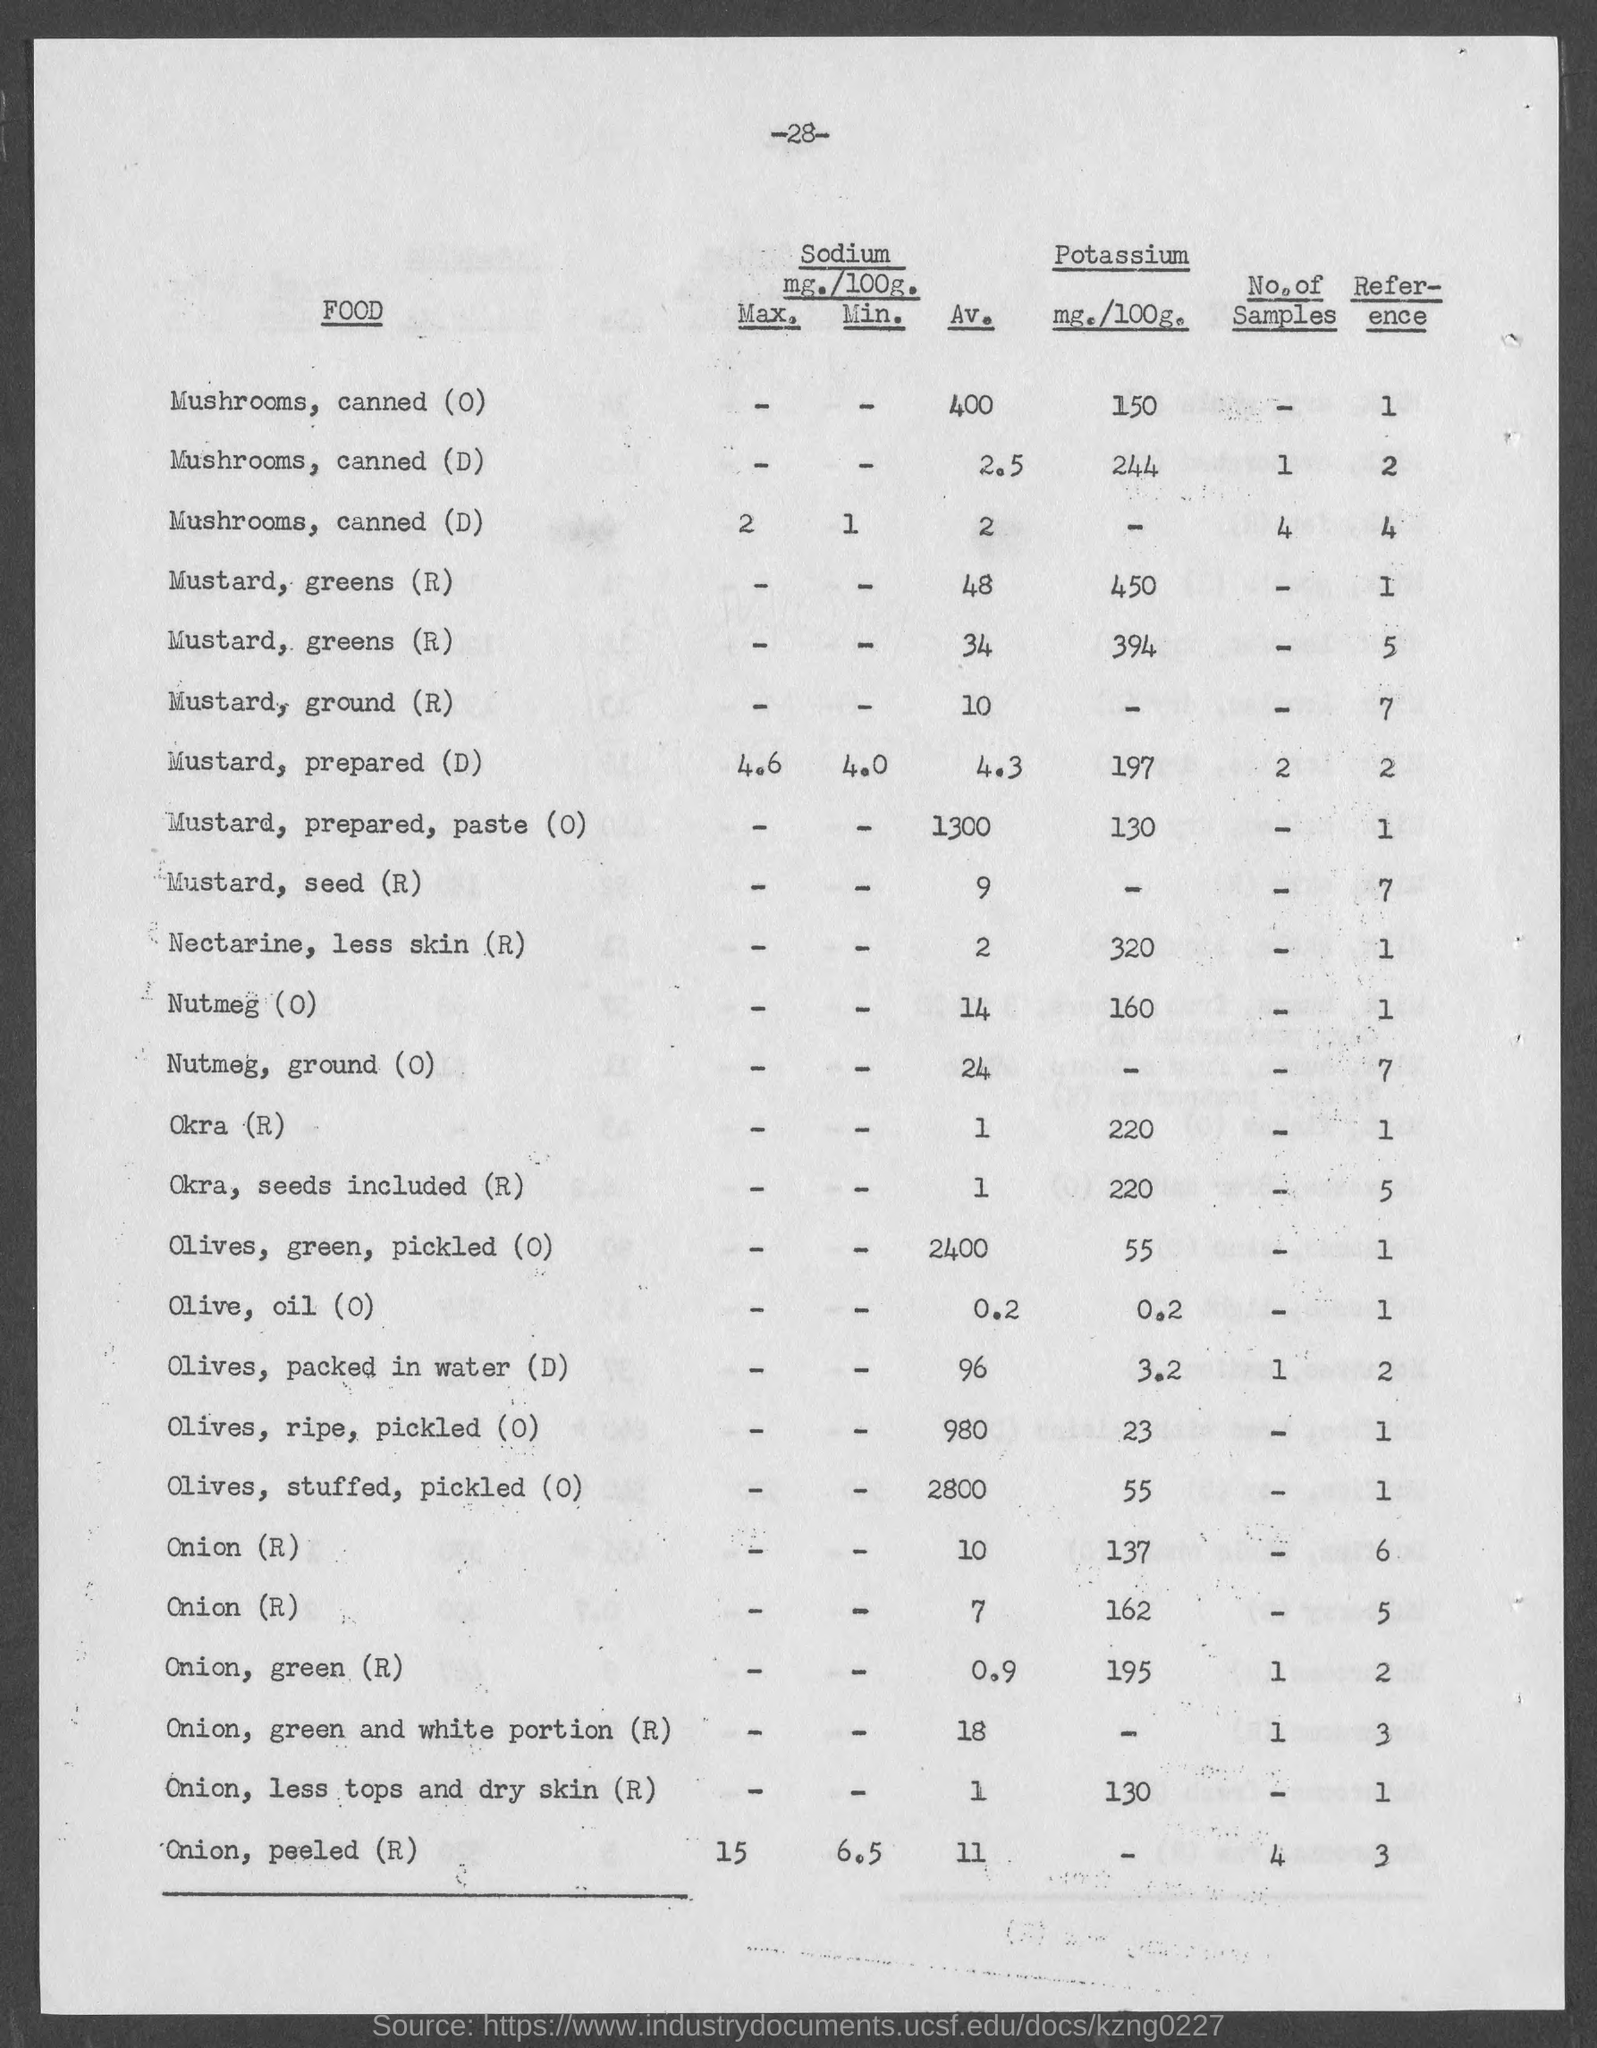List a handful of essential elements in this visual. The potassium content of Mustard, prepared (D) is 197 mg per 100 grams. The potassium content of okra, measured in milligrams per 100 grams, is 220. The potassium content of Mustard, prepared, paste (O) is 130 mg per 100 grams. The potassium content of nectarine with less skin (R) is approximately 320 milligrams per 100 grams. The potassium content of olive oil is approximately 0.2 milligrams per 100 grams. 